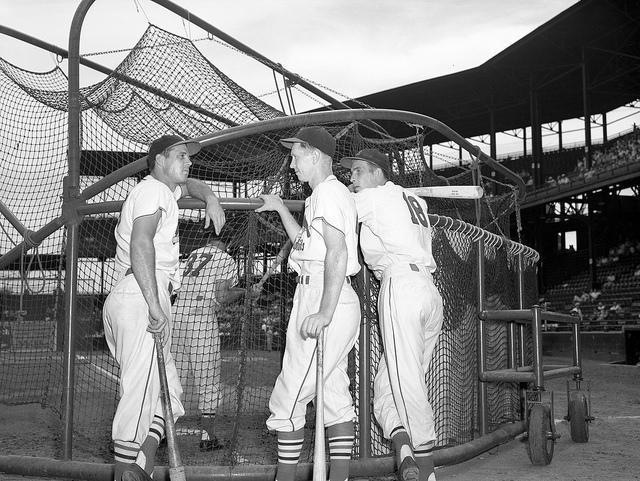How many bats are actually in use in the picture?
Give a very brief answer. 1. How many people are visible?
Give a very brief answer. 4. How many train cars are orange?
Give a very brief answer. 0. 